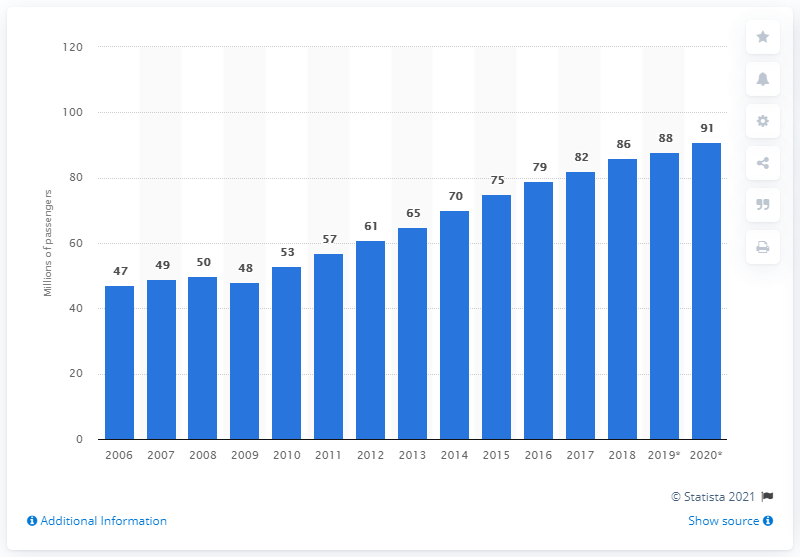Give some essential details in this illustration. In 2019, 88 Latin American passengers traveled to or from the United States. 